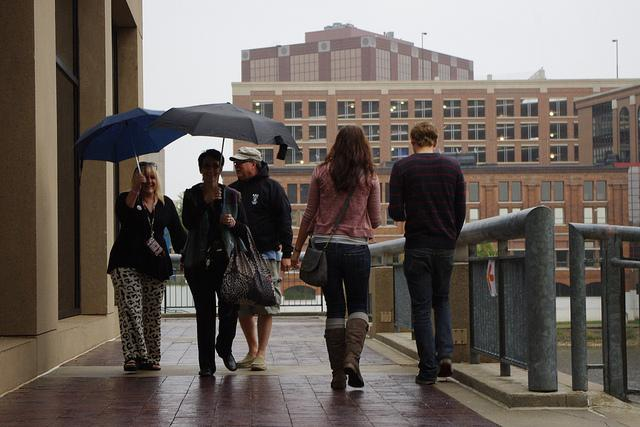What problem are the two people on the right facing?

Choices:
A) getting soaked
B) getting thirsty
C) getting tired
D) getting sunburned getting soaked 